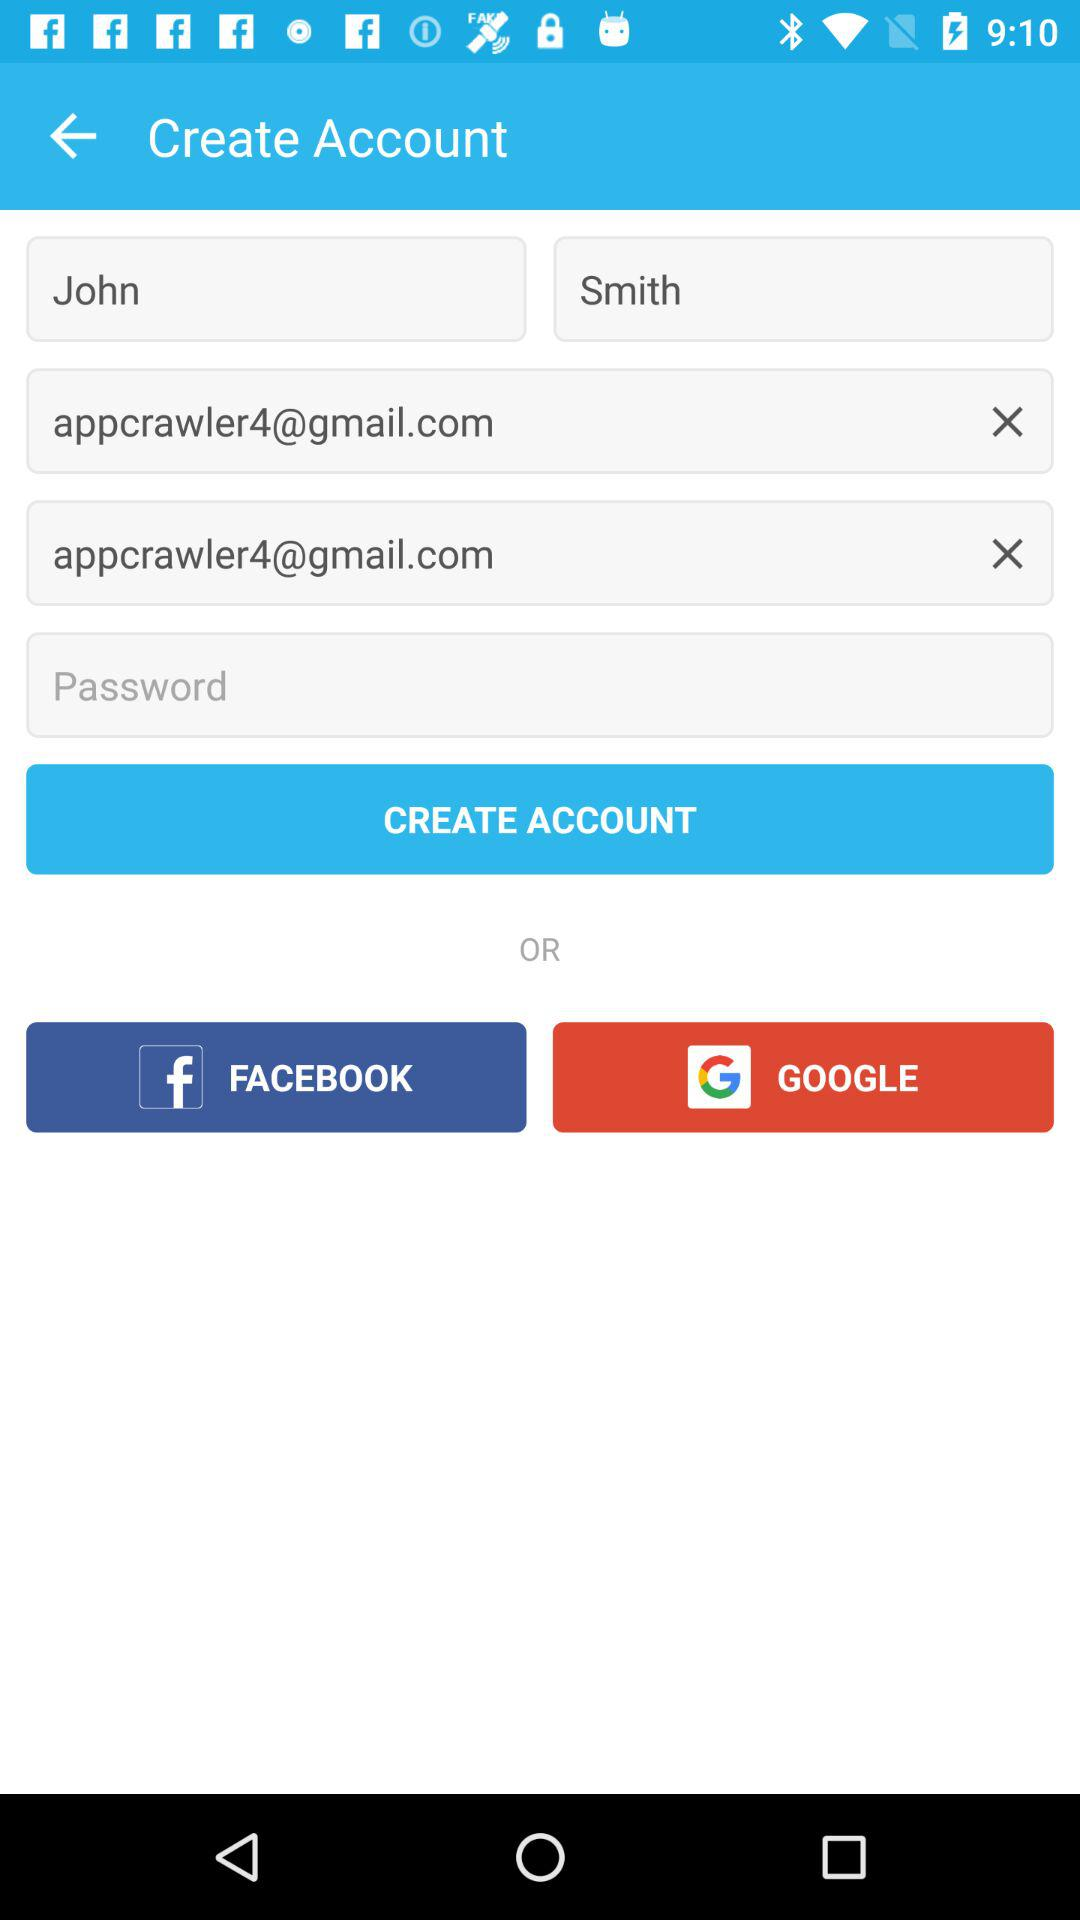What are the different options available for logging in? The different options available for logging in are "FACEBOOK" and "GOOGLE". 